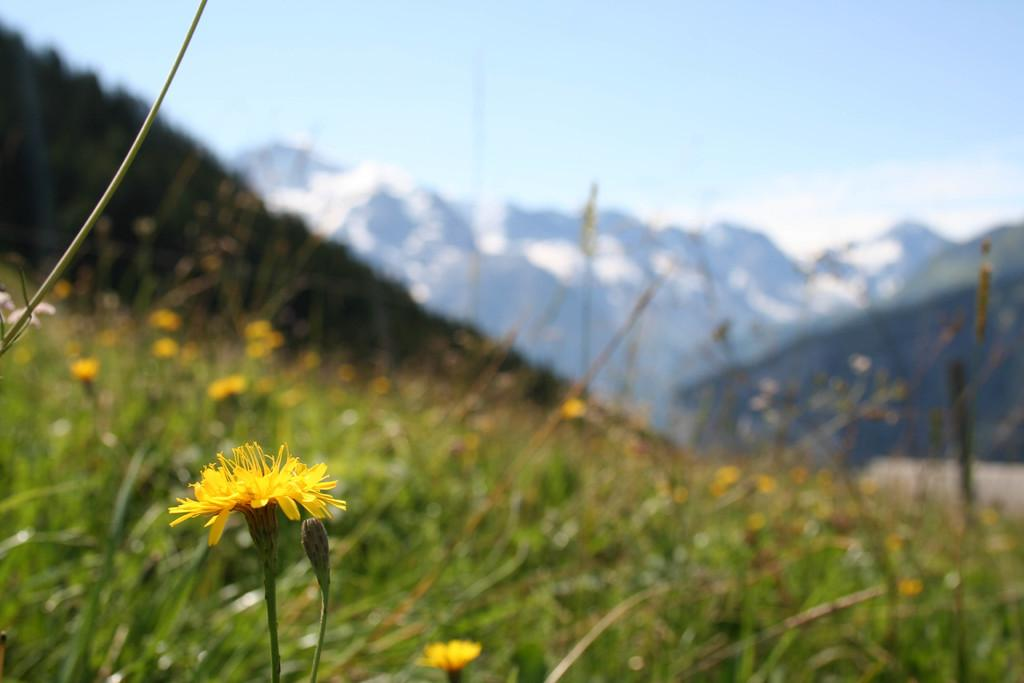What type of natural elements can be seen in the image? There are flowers, plants, hills, and mountains in the image. What part of the natural environment is visible in the image? The sky is visible in the image. Can you describe the landscape in the image? The image features a landscape with hills and mountains, along with flowers and plants. How many shoes can be seen on the mountains in the image? There are no shoes present in the image; it features natural elements such as flowers, plants, hills, and mountains. 